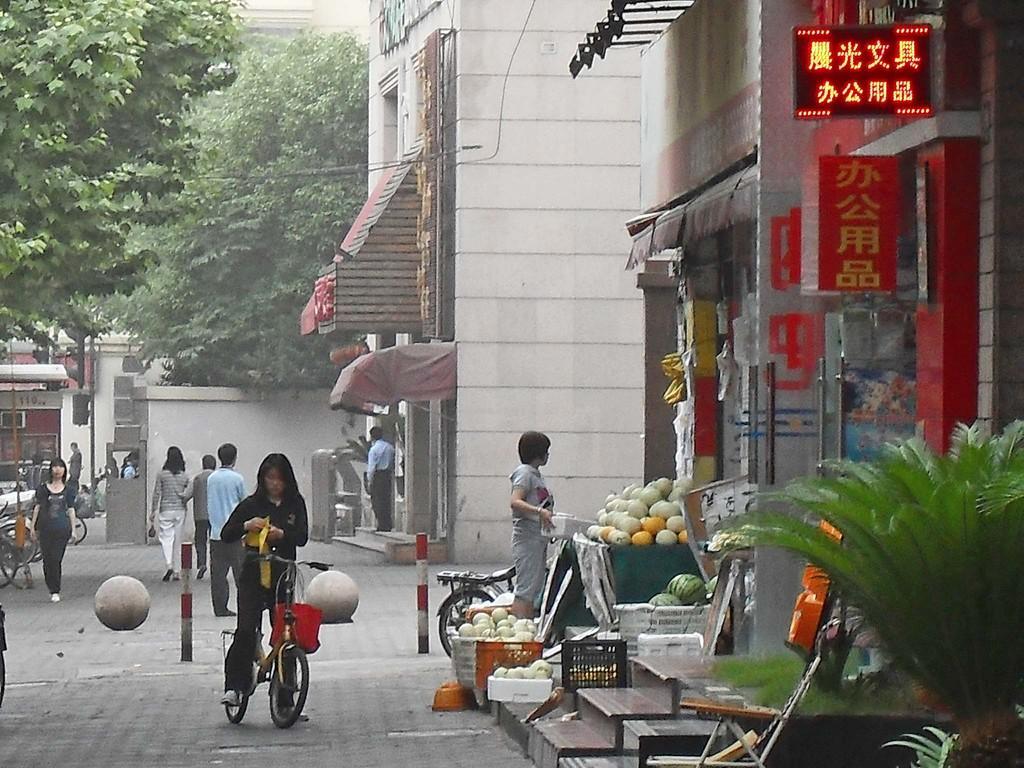How would you summarize this image in a sentence or two? In this image there is a girl wearing black color dress on a bicycle. To the right side of the image there are stores. There is a plant. In the background of the image there are trees. There is a building. There are people walking on the road. There are safety poles. 